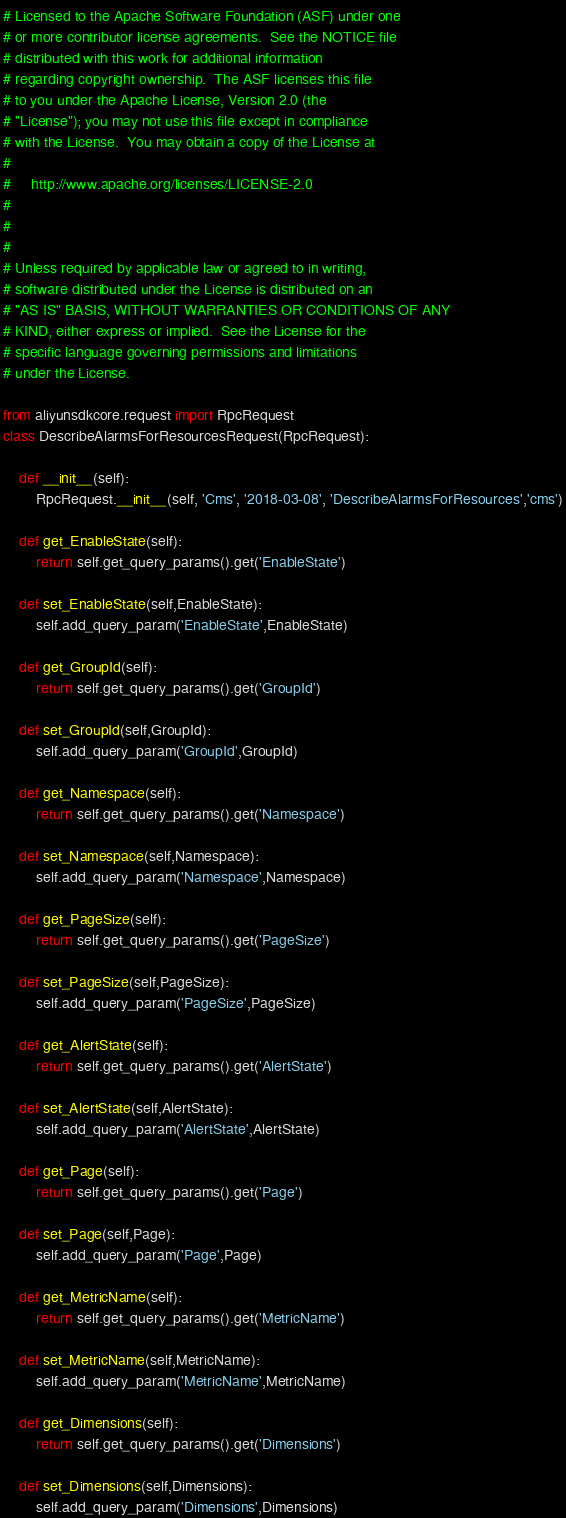<code> <loc_0><loc_0><loc_500><loc_500><_Python_># Licensed to the Apache Software Foundation (ASF) under one
# or more contributor license agreements.  See the NOTICE file
# distributed with this work for additional information
# regarding copyright ownership.  The ASF licenses this file
# to you under the Apache License, Version 2.0 (the
# "License"); you may not use this file except in compliance
# with the License.  You may obtain a copy of the License at
#
#     http://www.apache.org/licenses/LICENSE-2.0
#
#
#
# Unless required by applicable law or agreed to in writing,
# software distributed under the License is distributed on an
# "AS IS" BASIS, WITHOUT WARRANTIES OR CONDITIONS OF ANY
# KIND, either express or implied.  See the License for the
# specific language governing permissions and limitations
# under the License.

from aliyunsdkcore.request import RpcRequest
class DescribeAlarmsForResourcesRequest(RpcRequest):

	def __init__(self):
		RpcRequest.__init__(self, 'Cms', '2018-03-08', 'DescribeAlarmsForResources','cms')

	def get_EnableState(self):
		return self.get_query_params().get('EnableState')

	def set_EnableState(self,EnableState):
		self.add_query_param('EnableState',EnableState)

	def get_GroupId(self):
		return self.get_query_params().get('GroupId')

	def set_GroupId(self,GroupId):
		self.add_query_param('GroupId',GroupId)

	def get_Namespace(self):
		return self.get_query_params().get('Namespace')

	def set_Namespace(self,Namespace):
		self.add_query_param('Namespace',Namespace)

	def get_PageSize(self):
		return self.get_query_params().get('PageSize')

	def set_PageSize(self,PageSize):
		self.add_query_param('PageSize',PageSize)

	def get_AlertState(self):
		return self.get_query_params().get('AlertState')

	def set_AlertState(self,AlertState):
		self.add_query_param('AlertState',AlertState)

	def get_Page(self):
		return self.get_query_params().get('Page')

	def set_Page(self,Page):
		self.add_query_param('Page',Page)

	def get_MetricName(self):
		return self.get_query_params().get('MetricName')

	def set_MetricName(self,MetricName):
		self.add_query_param('MetricName',MetricName)

	def get_Dimensions(self):
		return self.get_query_params().get('Dimensions')

	def set_Dimensions(self,Dimensions):
		self.add_query_param('Dimensions',Dimensions)</code> 